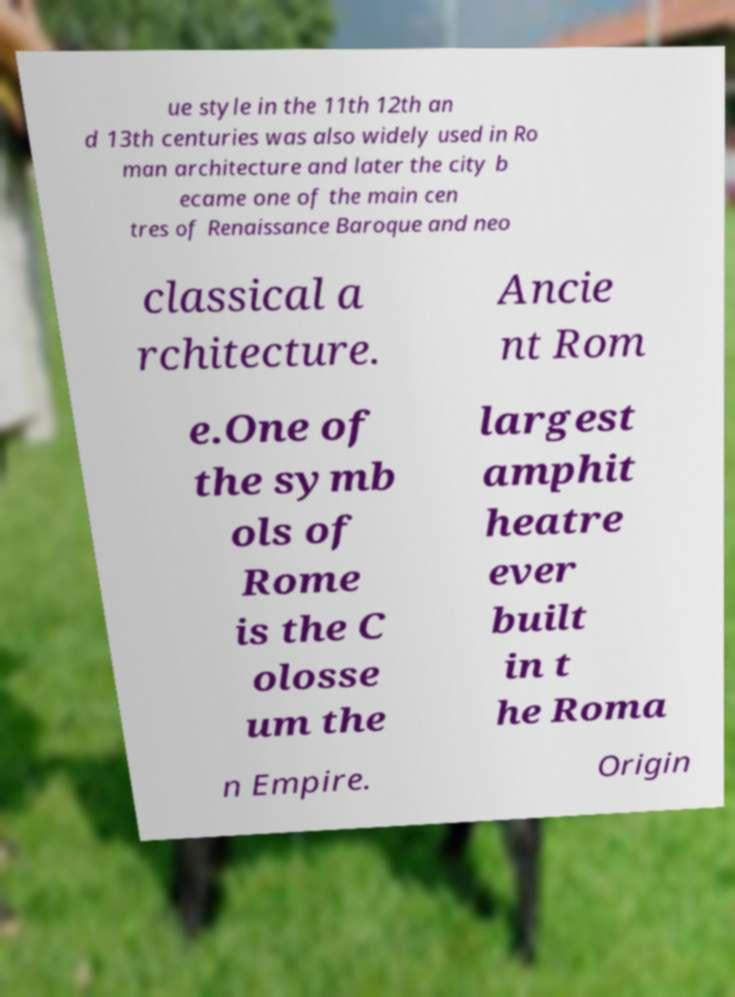Could you assist in decoding the text presented in this image and type it out clearly? ue style in the 11th 12th an d 13th centuries was also widely used in Ro man architecture and later the city b ecame one of the main cen tres of Renaissance Baroque and neo classical a rchitecture. Ancie nt Rom e.One of the symb ols of Rome is the C olosse um the largest amphit heatre ever built in t he Roma n Empire. Origin 